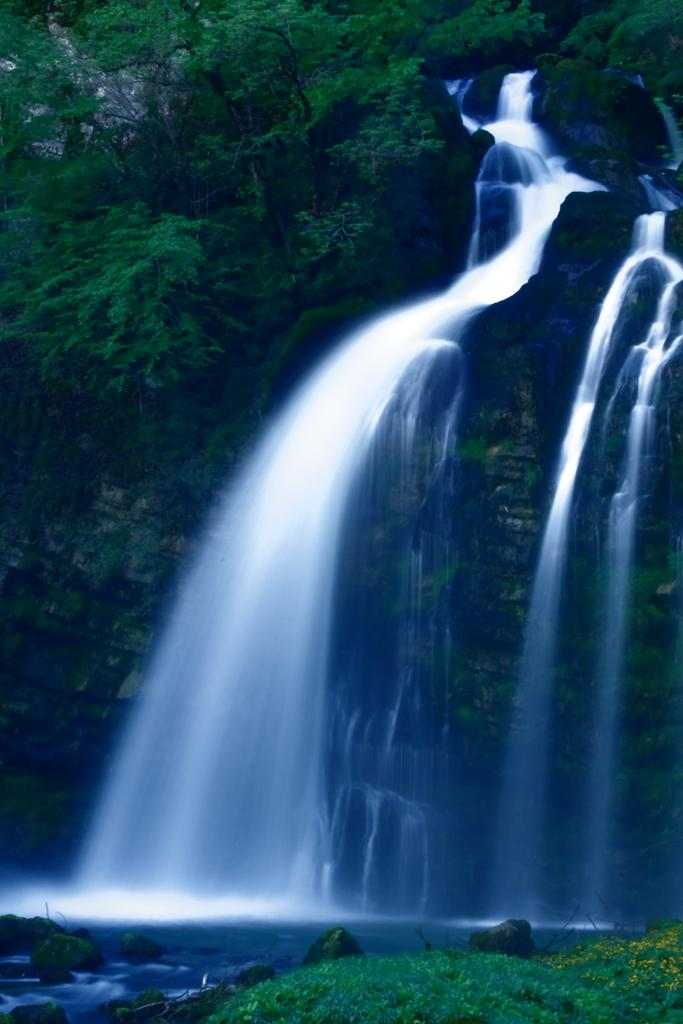What is the main feature in the image? There is a waterfall in the image. Where is the waterfall located in the image? The waterfall is in the middle of the image. What can be seen at the top of the image? There are trees at the top of the image. How many rings are visible in the image? There are no rings present in the image. Is there a crowd gathered around the waterfall in the image? There is no crowd visible in the image; it only features the waterfall and trees. 